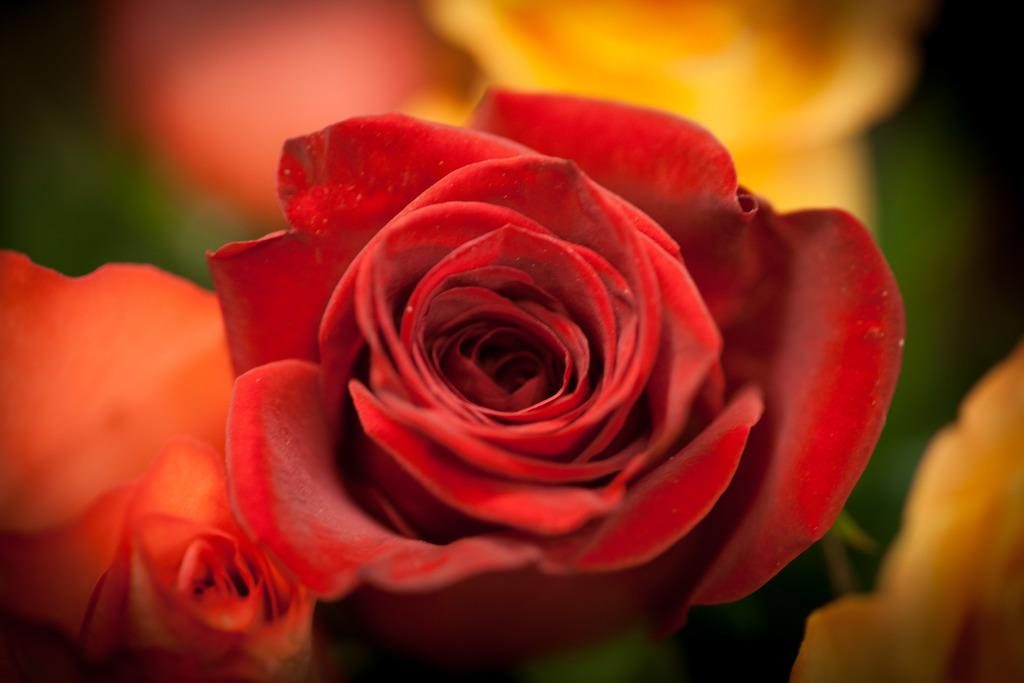How many roses are present in the image? There are two roses in the image. What are the colors of the roses? One rose is red in color, and the other rose is orange in color. What type of request can be seen written on the grass in the image? There is no grass or request present in the image; it only features two roses, one red and one orange. 